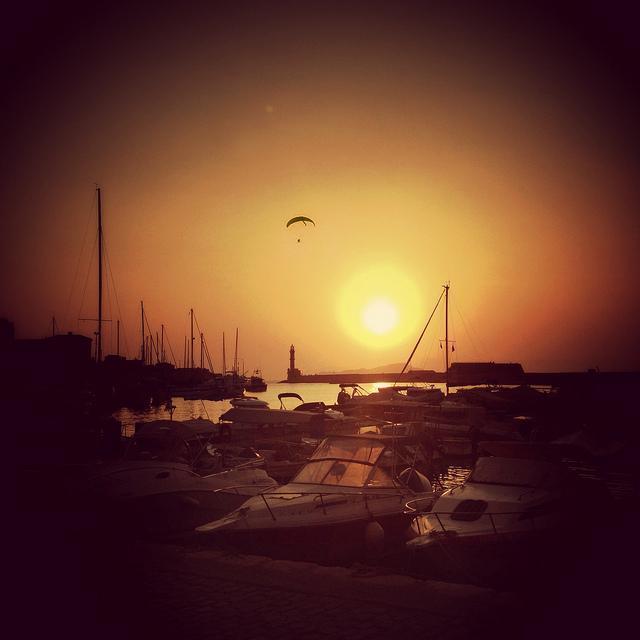How many boats are visible?
Give a very brief answer. 4. How many cars are visible in this photo?
Give a very brief answer. 0. 